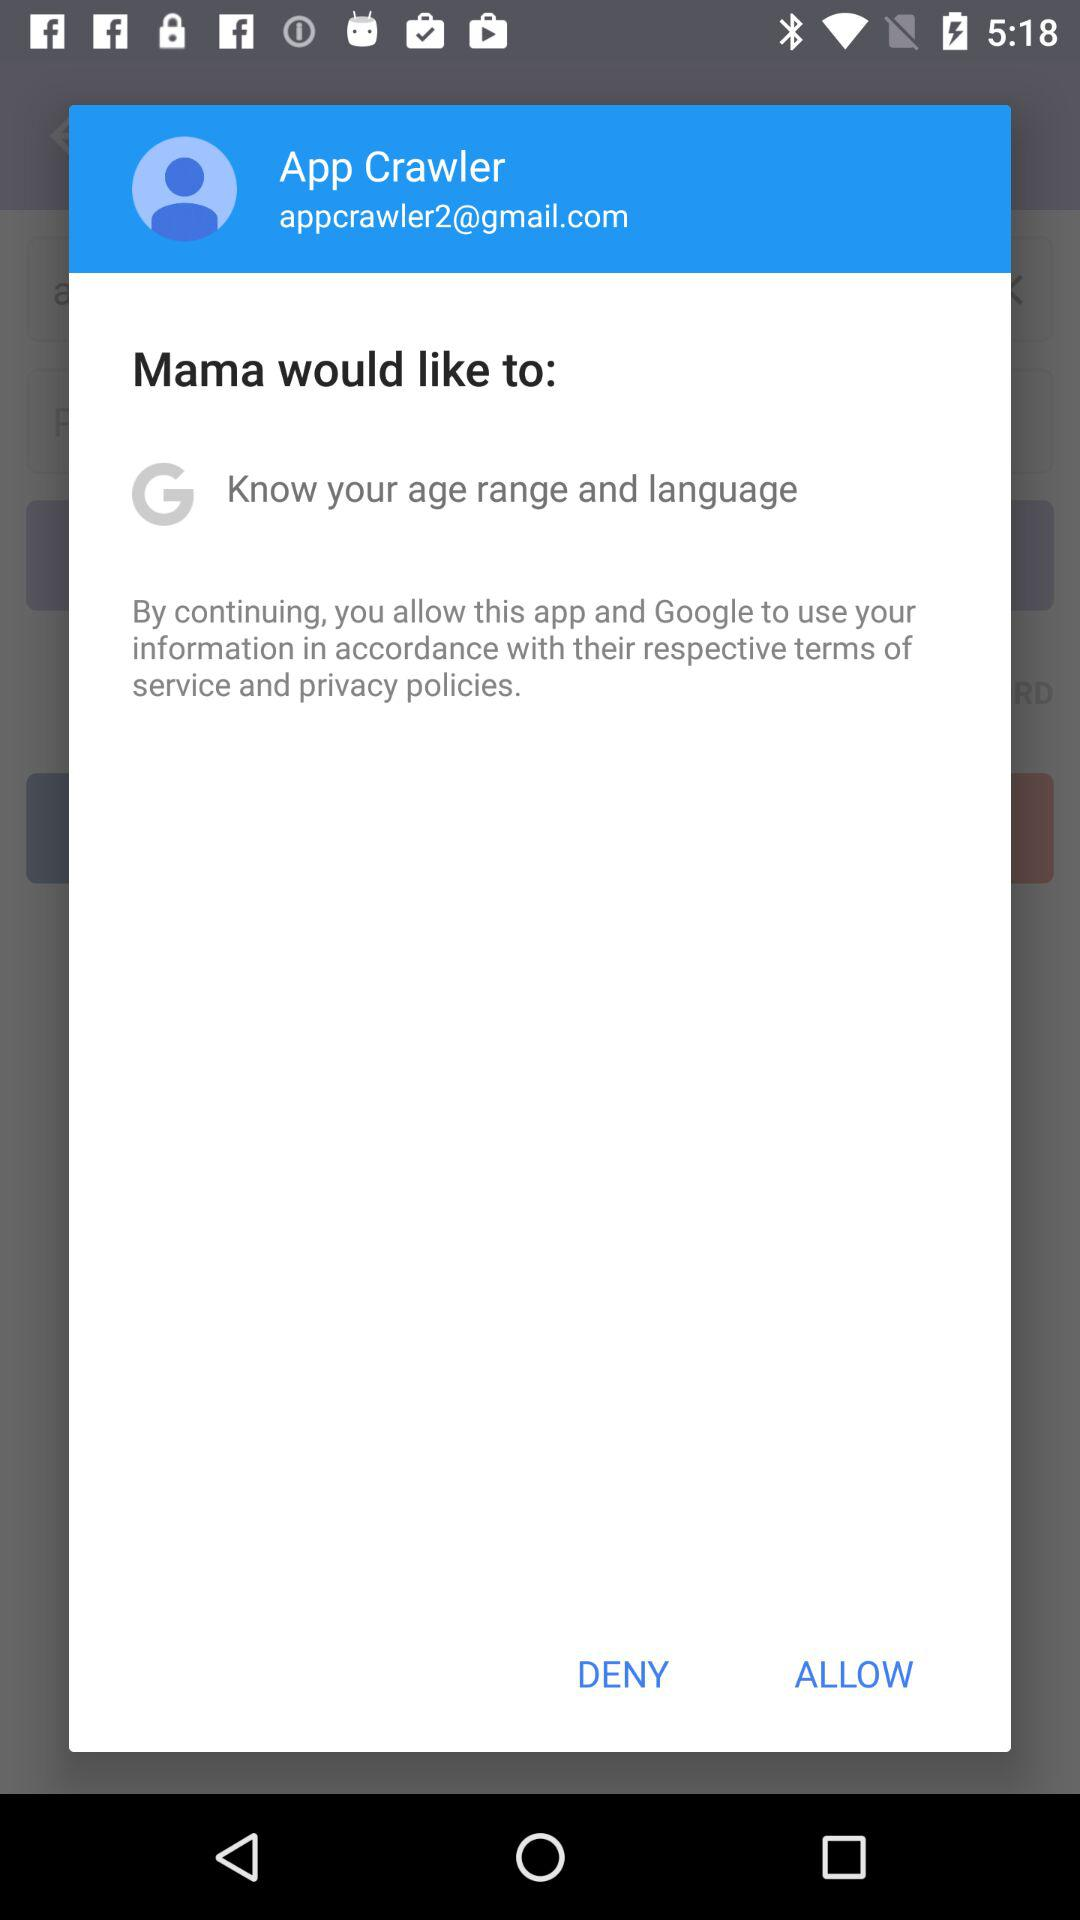What is the name of the user? The name of the user is App Crawler. 